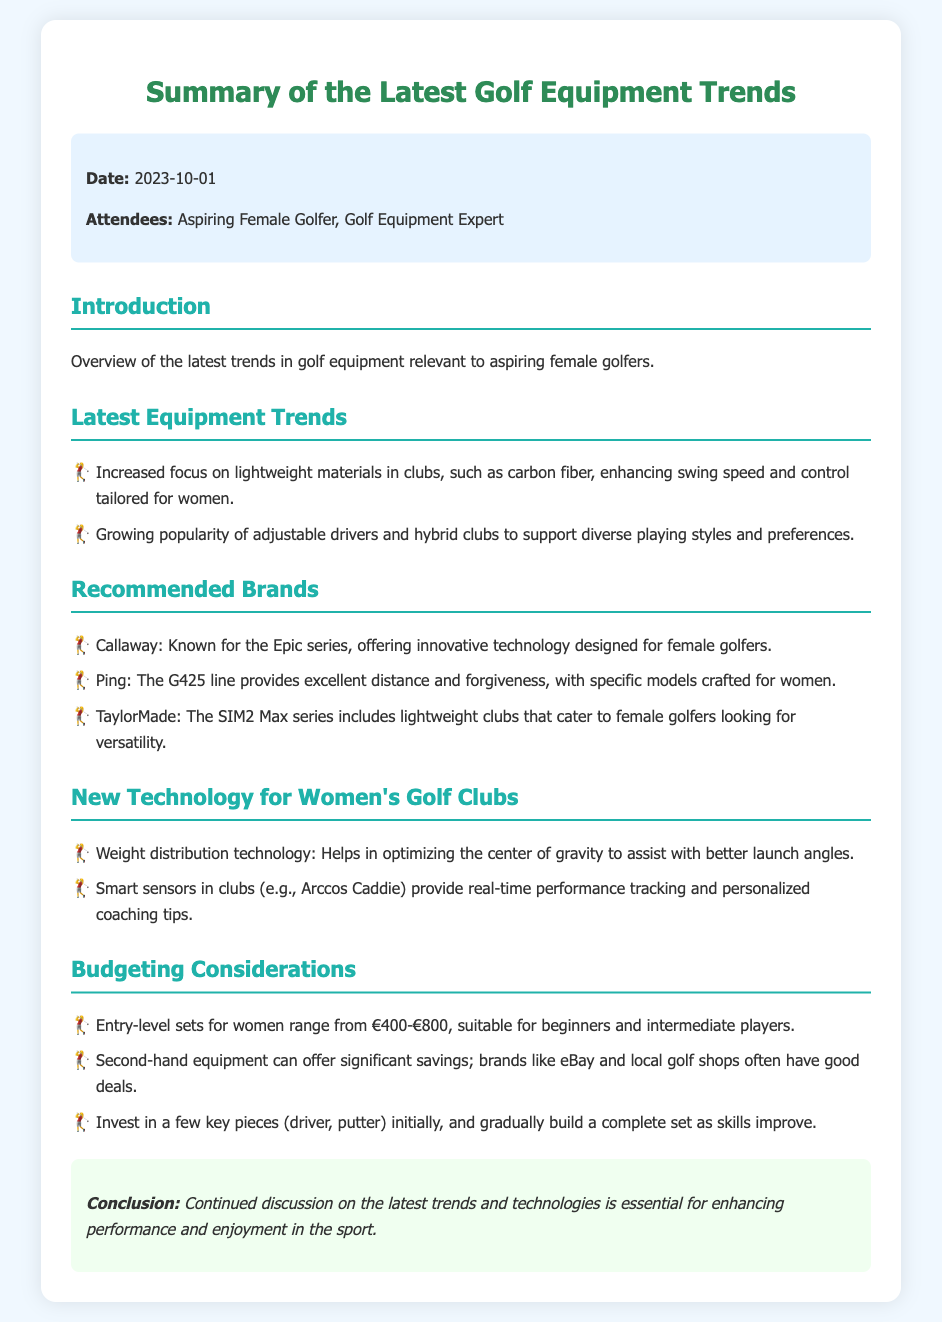What is the date of the meeting? The date is provided in the meta-info section of the document.
Answer: 2023-10-01 Who attended the meeting? The attendees are listed in the meta-info section, indicating who was present during the discussions.
Answer: Aspiring Female Golfer, Golf Equipment Expert Which brand is known for the Epic series? The document mentions Callaway specifically as the brand associated with the Epic series.
Answer: Callaway What technology helps optimize the center of gravity in clubs? The document specifically mentions weight distribution technology in the context of club design and performance.
Answer: Weight distribution technology What is the price range for entry-level sets for women? The document provides a specific price range for entry-level golf equipment targeted at women.
Answer: €400-€800 Which brand provides the G425 line? The document identifies the brand associated with the G425 line of clubs aimed at female golfers.
Answer: Ping What should be the initial investment in key pieces of equipment? The document suggests investing in a few important clubs at the beginning for new golfers.
Answer: Driver, putter What is one way to save on golf equipment? The document mentions an option for finding more affordable options for golf gear.
Answer: Second-hand equipment 